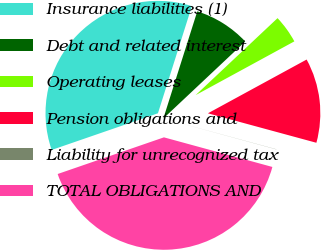Convert chart to OTSL. <chart><loc_0><loc_0><loc_500><loc_500><pie_chart><fcel>Insurance liabilities (1)<fcel>Debt and related interest<fcel>Operating leases<fcel>Pension obligations and<fcel>Liability for unrecognized tax<fcel>TOTAL OBLIGATIONS AND<nl><fcel>35.17%<fcel>8.11%<fcel>4.07%<fcel>12.16%<fcel>0.02%<fcel>40.47%<nl></chart> 